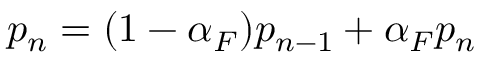Convert formula to latex. <formula><loc_0><loc_0><loc_500><loc_500>p _ { n } = ( 1 - \alpha _ { F } ) p _ { n - 1 } + \alpha _ { F } p _ { n }</formula> 